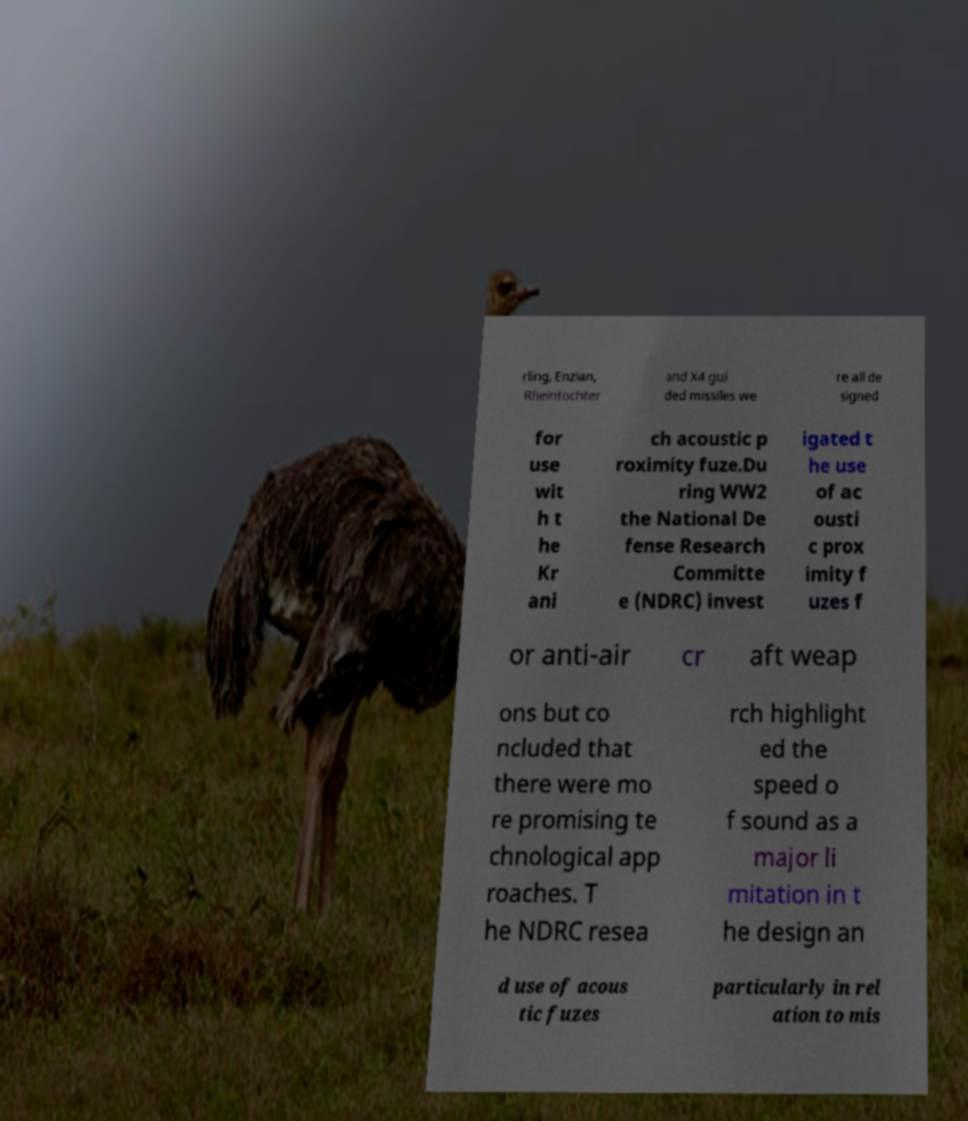What messages or text are displayed in this image? I need them in a readable, typed format. rling, Enzian, Rheintochter and X4 gui ded missiles we re all de signed for use wit h t he Kr ani ch acoustic p roximity fuze.Du ring WW2 the National De fense Research Committe e (NDRC) invest igated t he use of ac ousti c prox imity f uzes f or anti-air cr aft weap ons but co ncluded that there were mo re promising te chnological app roaches. T he NDRC resea rch highlight ed the speed o f sound as a major li mitation in t he design an d use of acous tic fuzes particularly in rel ation to mis 